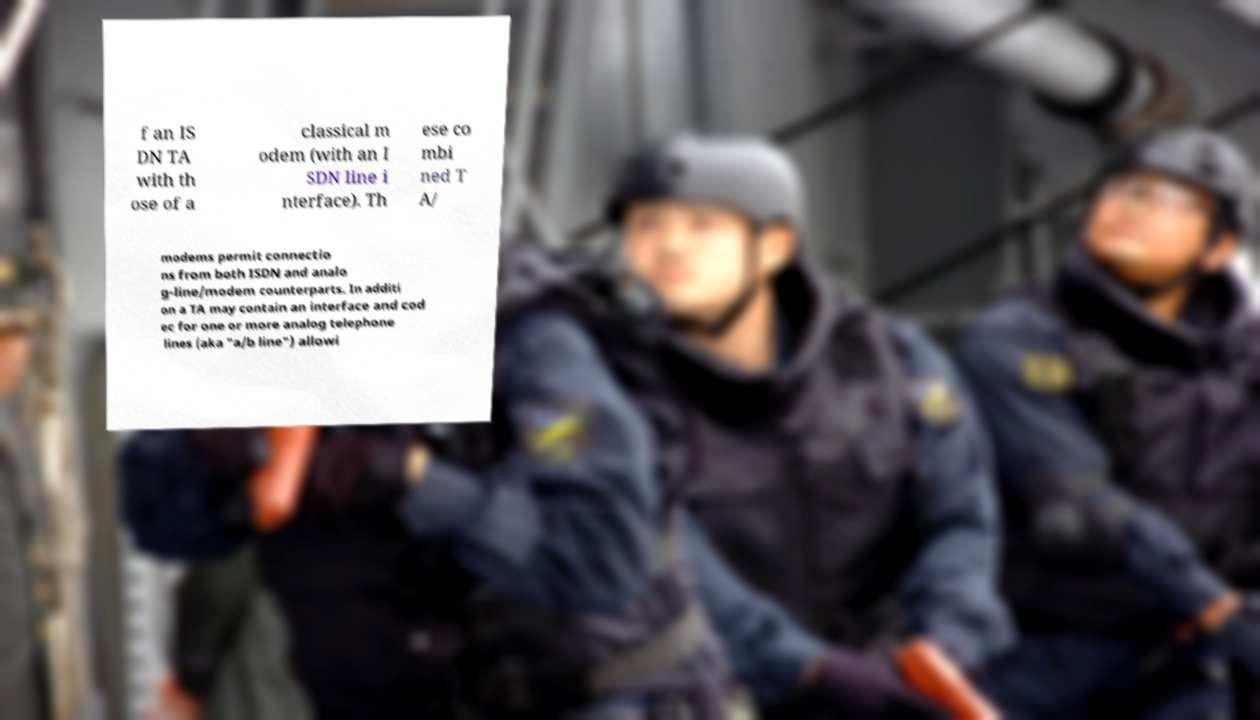For documentation purposes, I need the text within this image transcribed. Could you provide that? f an IS DN TA with th ose of a classical m odem (with an I SDN line i nterface). Th ese co mbi ned T A/ modems permit connectio ns from both ISDN and analo g-line/modem counterparts. In additi on a TA may contain an interface and cod ec for one or more analog telephone lines (aka "a/b line") allowi 